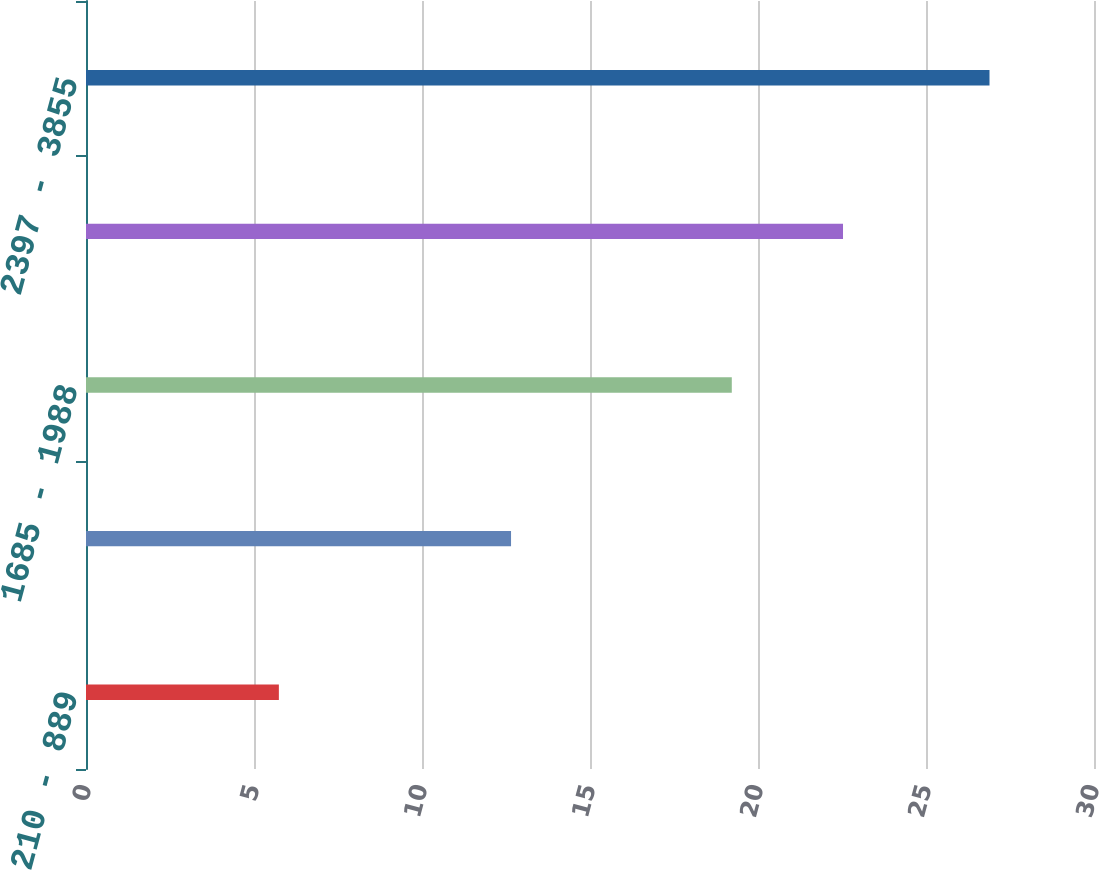Convert chart. <chart><loc_0><loc_0><loc_500><loc_500><bar_chart><fcel>210 - 889<fcel>899 - 1582<fcel>1685 - 1988<fcel>1989 - 2378<fcel>2397 - 3855<nl><fcel>5.74<fcel>12.65<fcel>19.22<fcel>22.53<fcel>26.89<nl></chart> 